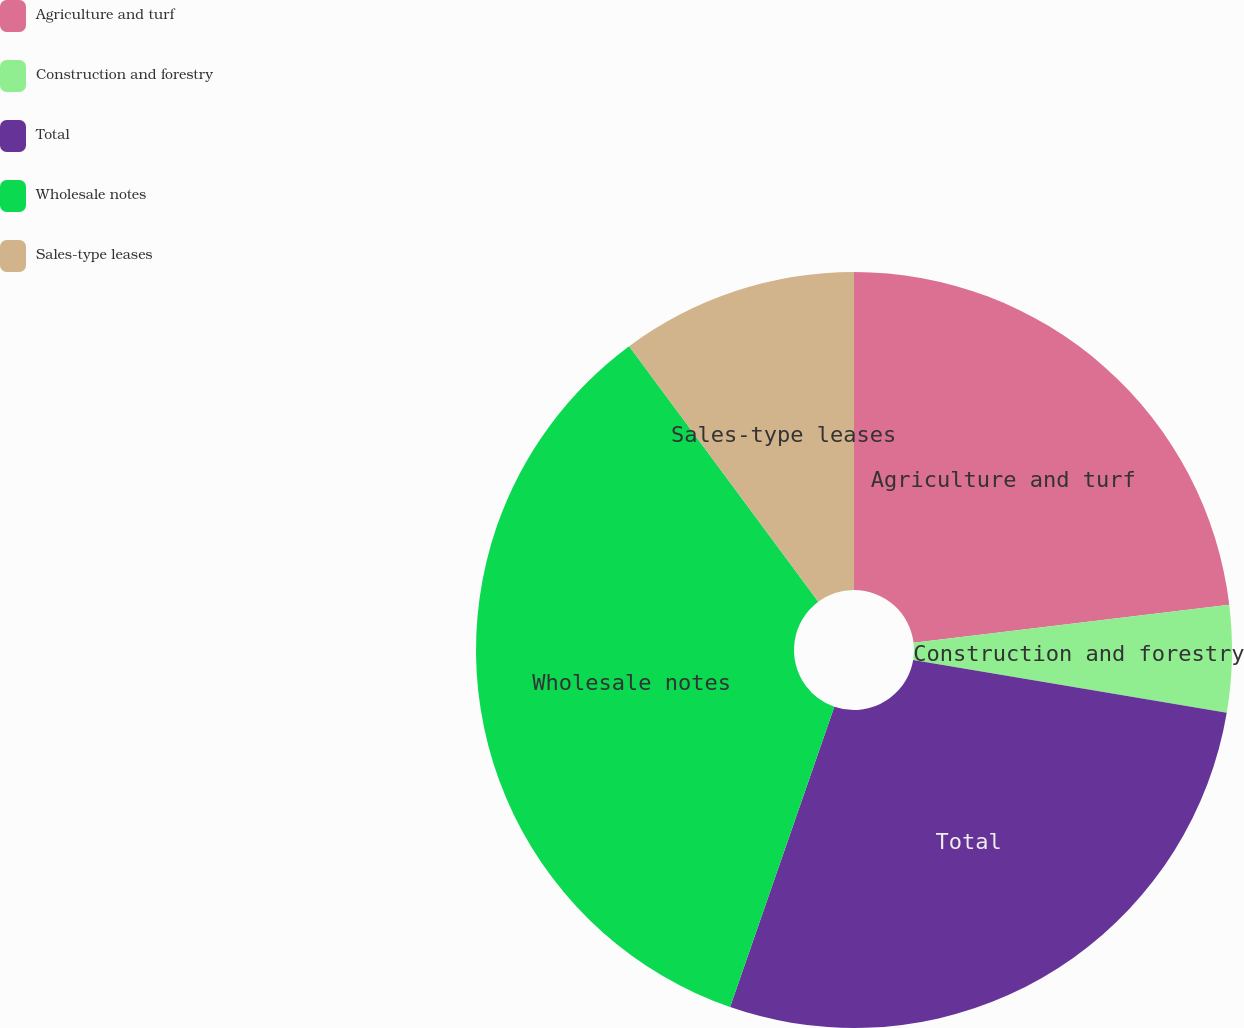<chart> <loc_0><loc_0><loc_500><loc_500><pie_chart><fcel>Agriculture and turf<fcel>Construction and forestry<fcel>Total<fcel>Wholesale notes<fcel>Sales-type leases<nl><fcel>23.09%<fcel>4.57%<fcel>27.66%<fcel>34.55%<fcel>10.14%<nl></chart> 